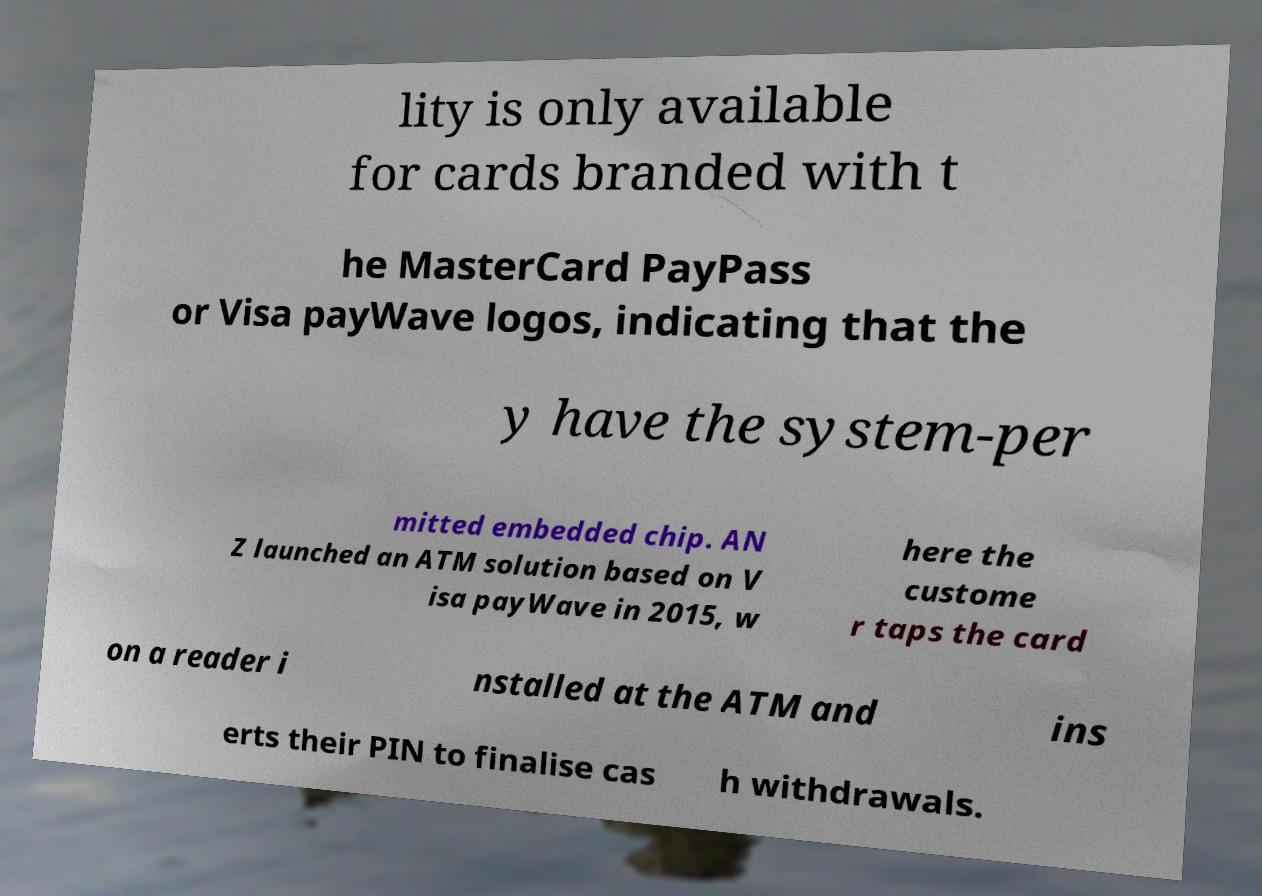Can you read and provide the text displayed in the image?This photo seems to have some interesting text. Can you extract and type it out for me? lity is only available for cards branded with t he MasterCard PayPass or Visa payWave logos, indicating that the y have the system-per mitted embedded chip. AN Z launched an ATM solution based on V isa payWave in 2015, w here the custome r taps the card on a reader i nstalled at the ATM and ins erts their PIN to finalise cas h withdrawals. 